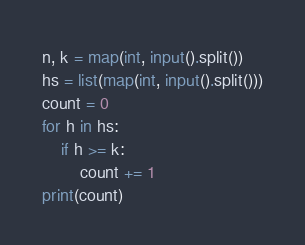<code> <loc_0><loc_0><loc_500><loc_500><_Python_>n, k = map(int, input().split())
hs = list(map(int, input().split()))
count = 0
for h in hs:
    if h >= k:
        count += 1
print(count)</code> 